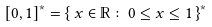<formula> <loc_0><loc_0><loc_500><loc_500>[ 0 , 1 ] ^ { \ast } = \{ \, x \in \mathbb { R } \colon 0 \leq x \leq 1 \, \} ^ { \ast }</formula> 